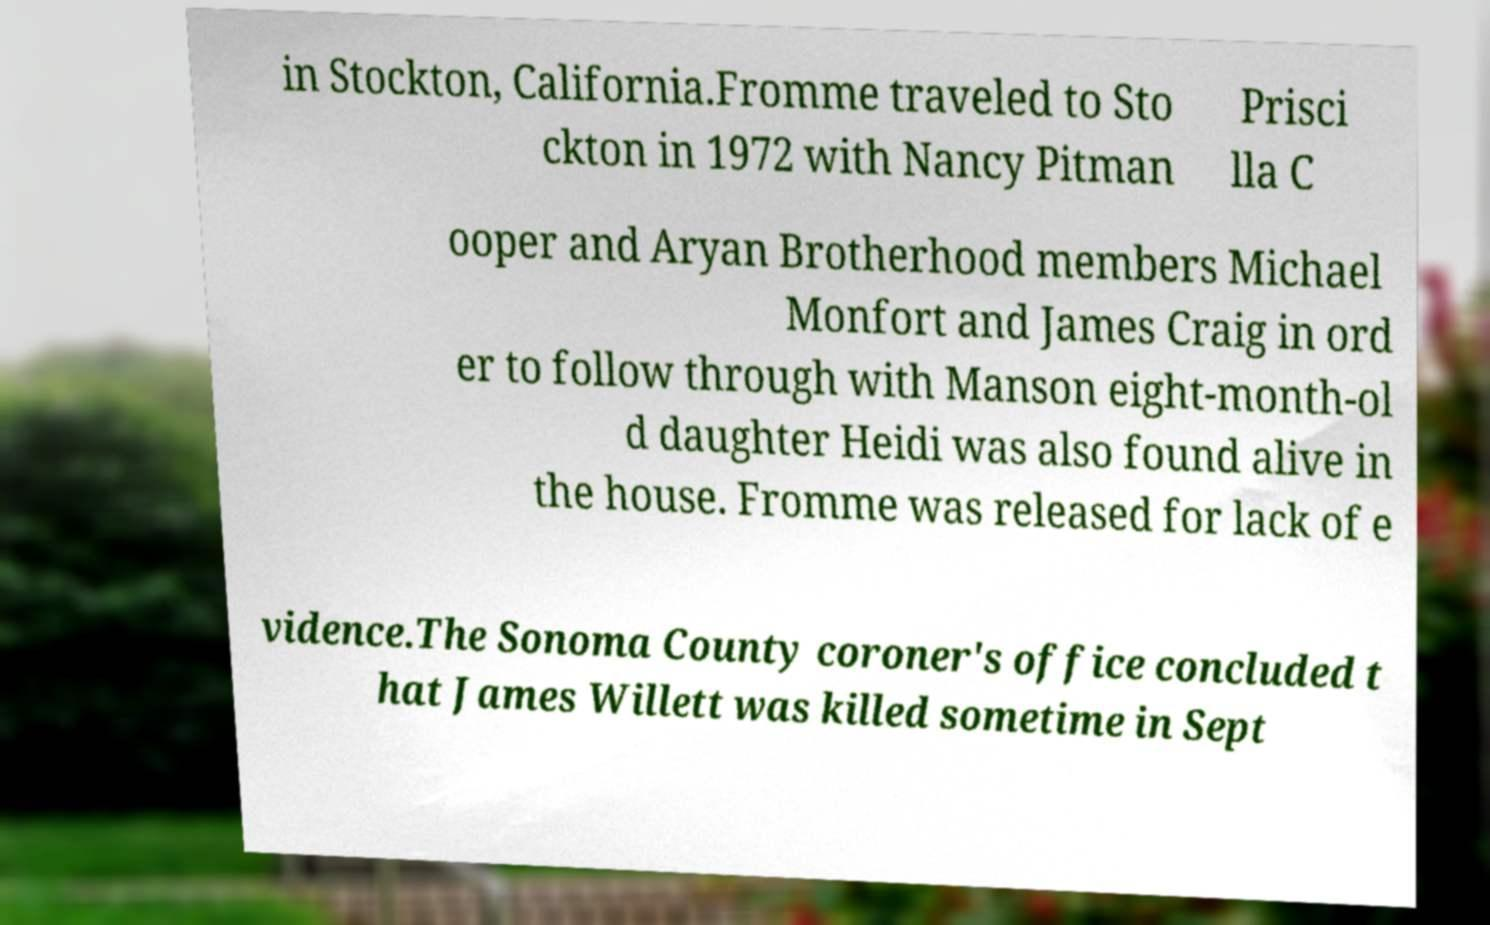Can you accurately transcribe the text from the provided image for me? in Stockton, California.Fromme traveled to Sto ckton in 1972 with Nancy Pitman Prisci lla C ooper and Aryan Brotherhood members Michael Monfort and James Craig in ord er to follow through with Manson eight-month-ol d daughter Heidi was also found alive in the house. Fromme was released for lack of e vidence.The Sonoma County coroner's office concluded t hat James Willett was killed sometime in Sept 